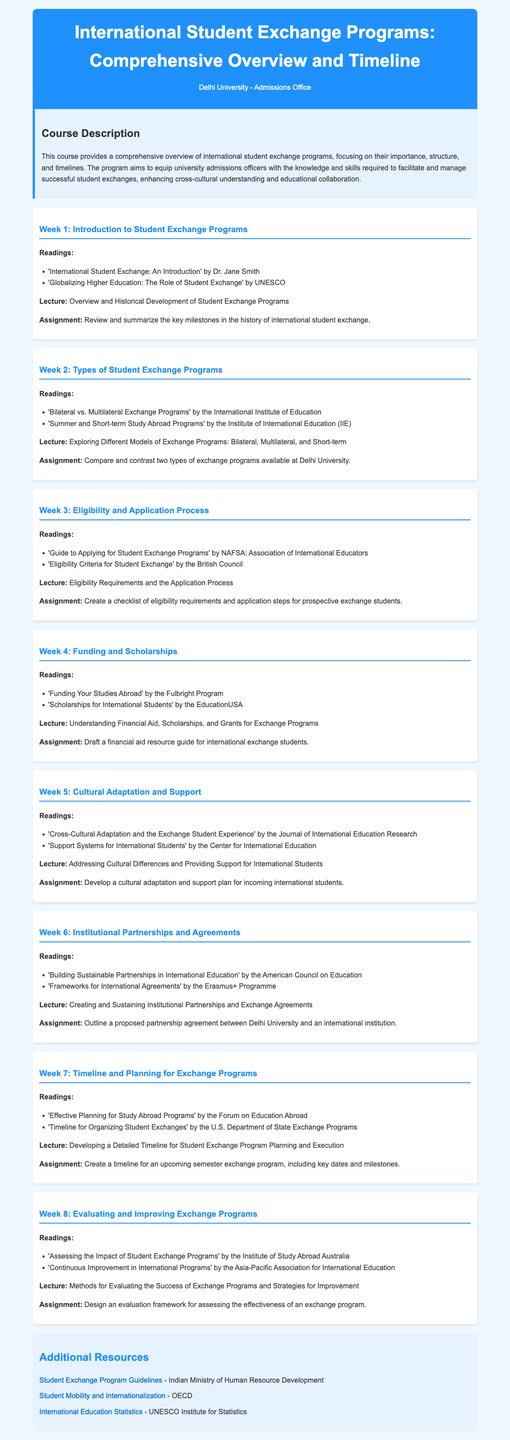What is the title of the course? The title of the course is stated in the header of the document.
Answer: International Student Exchange Programs: Comprehensive Overview and Timeline Who authored the reading "International Student Exchange: An Introduction"? The author of this reading is mentioned in Week 1 readings.
Answer: Dr. Jane Smith What is the main focus of Week 4's lecture? The focus of Week 4's lecture is provided in the content describing the week's theme.
Answer: Understanding Financial Aid, Scholarships, and Grants for Exchange Programs How many weeks are covered in the syllabus? The number of weeks is summarized in the structure of the document.
Answer: Eight What type of partnership does Week 6 focus on? The week’s focus is indicated in the title and lecture description of the week.
Answer: Institutional Partnerships and Agreements What is the assignment for Week 7? The assignment details are explicitly stated in the content for Week 7.
Answer: Create a timeline for an upcoming semester exchange program, including key dates and milestones What is one resource available for additional information? The additional resources section lists various resources available for further reading.
Answer: Student Exchange Program Guidelines What is the purpose of the course as stated in the document? The purpose of the course is outlined in the course description section.
Answer: To equip university admissions officers with the knowledge and skills required to facilitate and manage successful student exchanges 